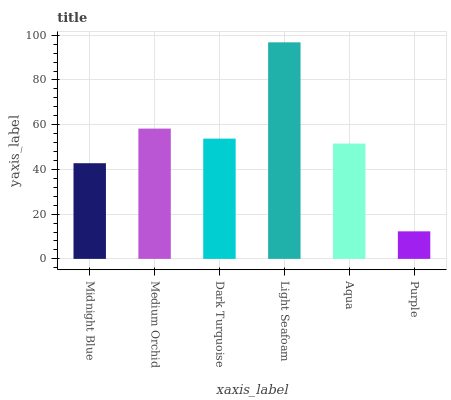Is Purple the minimum?
Answer yes or no. Yes. Is Light Seafoam the maximum?
Answer yes or no. Yes. Is Medium Orchid the minimum?
Answer yes or no. No. Is Medium Orchid the maximum?
Answer yes or no. No. Is Medium Orchid greater than Midnight Blue?
Answer yes or no. Yes. Is Midnight Blue less than Medium Orchid?
Answer yes or no. Yes. Is Midnight Blue greater than Medium Orchid?
Answer yes or no. No. Is Medium Orchid less than Midnight Blue?
Answer yes or no. No. Is Dark Turquoise the high median?
Answer yes or no. Yes. Is Aqua the low median?
Answer yes or no. Yes. Is Light Seafoam the high median?
Answer yes or no. No. Is Medium Orchid the low median?
Answer yes or no. No. 